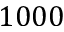<formula> <loc_0><loc_0><loc_500><loc_500>1 0 0 0</formula> 